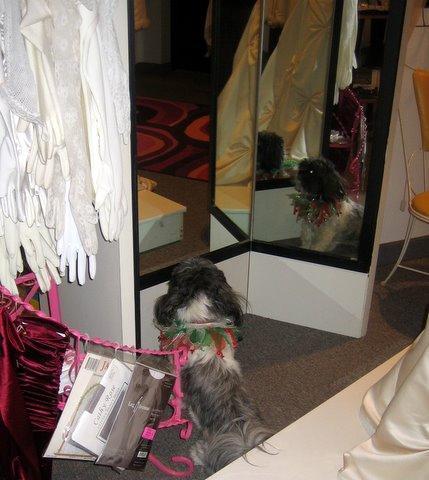How many mirrors?
Give a very brief answer. 2. How many books are there?
Give a very brief answer. 2. How many dogs are there?
Give a very brief answer. 2. How many birds are standing in the pizza box?
Give a very brief answer. 0. 